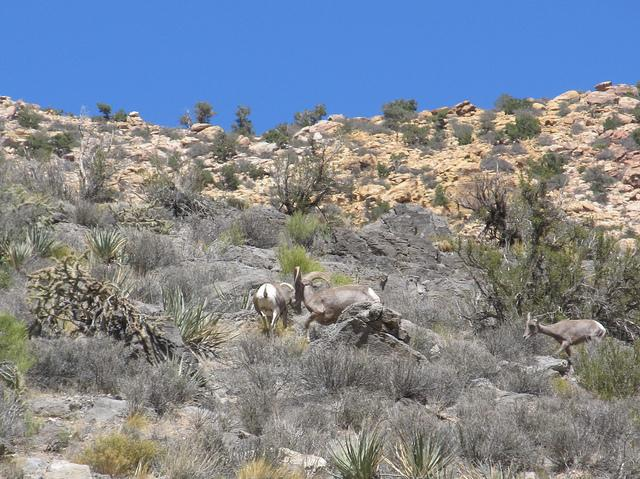What does the sky depict about the weather? Please explain your reasoning. clear. The sky is blue without a cloud in sight. the weather is good. 